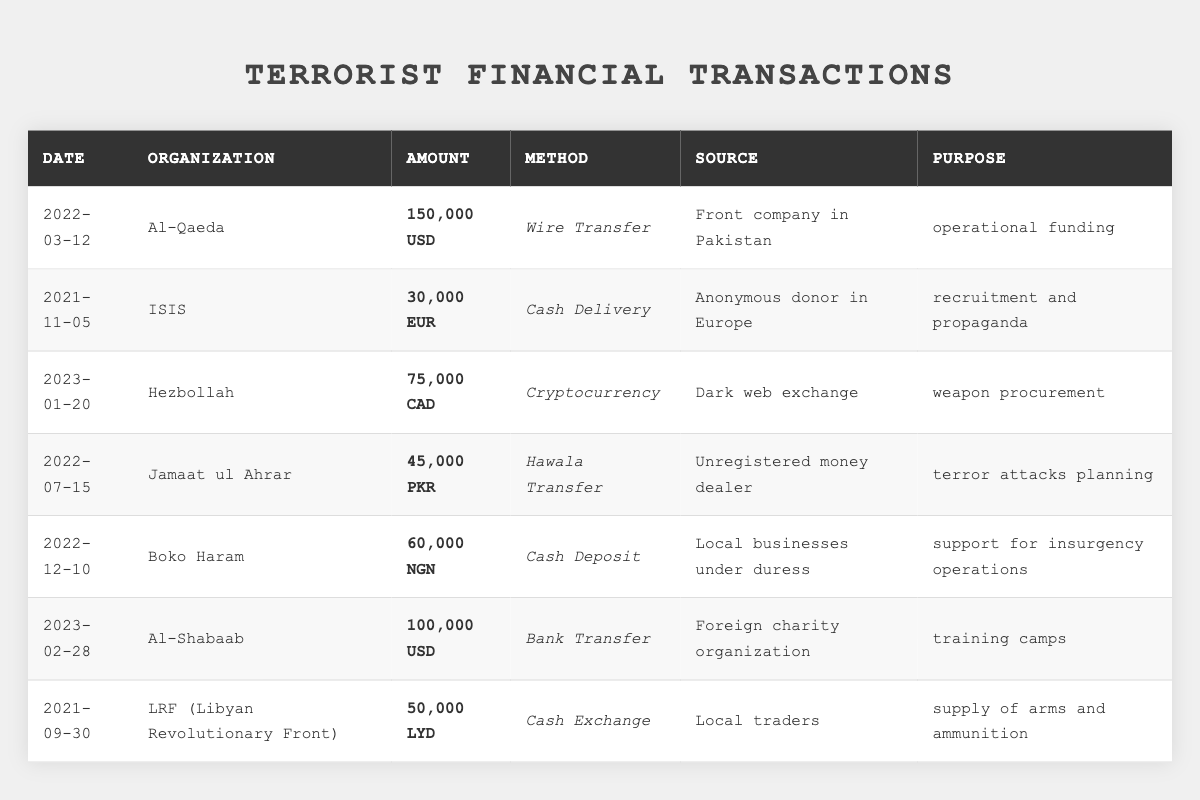What is the total amount of transactions recorded for Al-Qaeda? There is only one transaction recorded for Al-Qaeda, amounting to 150,000 USD.
Answer: 150,000 USD How many different organizations are listed in the table? The table lists seven different organizations: Al-Qaeda, ISIS, Hezbollah, Jamaat ul Ahrar, Boko Haram, Al-Shabaab, and LRF.
Answer: 7 What is the transaction method used by Boko Haram? Boko Haram used a Cash Deposit for their transaction.
Answer: Cash Deposit Which organization received the highest transaction amount and what was the amount? Al-Qaeda received the highest transaction amount of 150,000 USD.
Answer: Al-Qaeda, 150,000 USD What is the total transaction amount for all organizations in USD? The transactions for Al-Qaeda and Al-Shabaab are in USD (150,000 + 100,000), totaling 250,000 USD. Other amounts in different currencies need to be converted for an accurate total. Initially, only the USD transactions sum up to 250,000 USD.
Answer: 250,000 USD (without currency conversion for others) Is there a transaction from an anonymous donor? Yes, ISIS received a transaction from an anonymous donor in Europe.
Answer: Yes What percentage of the total transactions is made up by Hezbollah's transaction? First, calculate the total of all transactions: 150,000 + 30,000 + 75,000 + 45,000 + 60,000 + 100,000 + 50,000 = 510,000. Then, Hezbollah's transaction of 75,000 is 75,000/510,000 = 0.147, which is about 14.7%.
Answer: Approximately 14.7% Which organizations are involved in cash-based transaction methods? The organizations involved in cash-based transactions are ISIS (Cash Delivery), Boko Haram (Cash Deposit), and LRF (Cash Exchange).
Answer: ISIS, Boko Haram, LRF What is the transaction purpose for Al-Shabaab? The transaction purpose for Al-Shabaab is training camps.
Answer: Training camps Which organization has a transaction source from the dark web? Hezbollah has a transaction source from a dark web exchange.
Answer: Hezbollah 